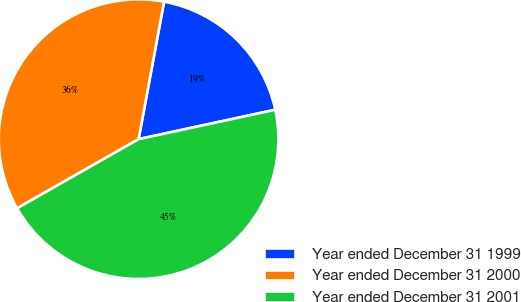Convert chart. <chart><loc_0><loc_0><loc_500><loc_500><pie_chart><fcel>Year ended December 31 1999<fcel>Year ended December 31 2000<fcel>Year ended December 31 2001<nl><fcel>18.71%<fcel>36.15%<fcel>45.14%<nl></chart> 